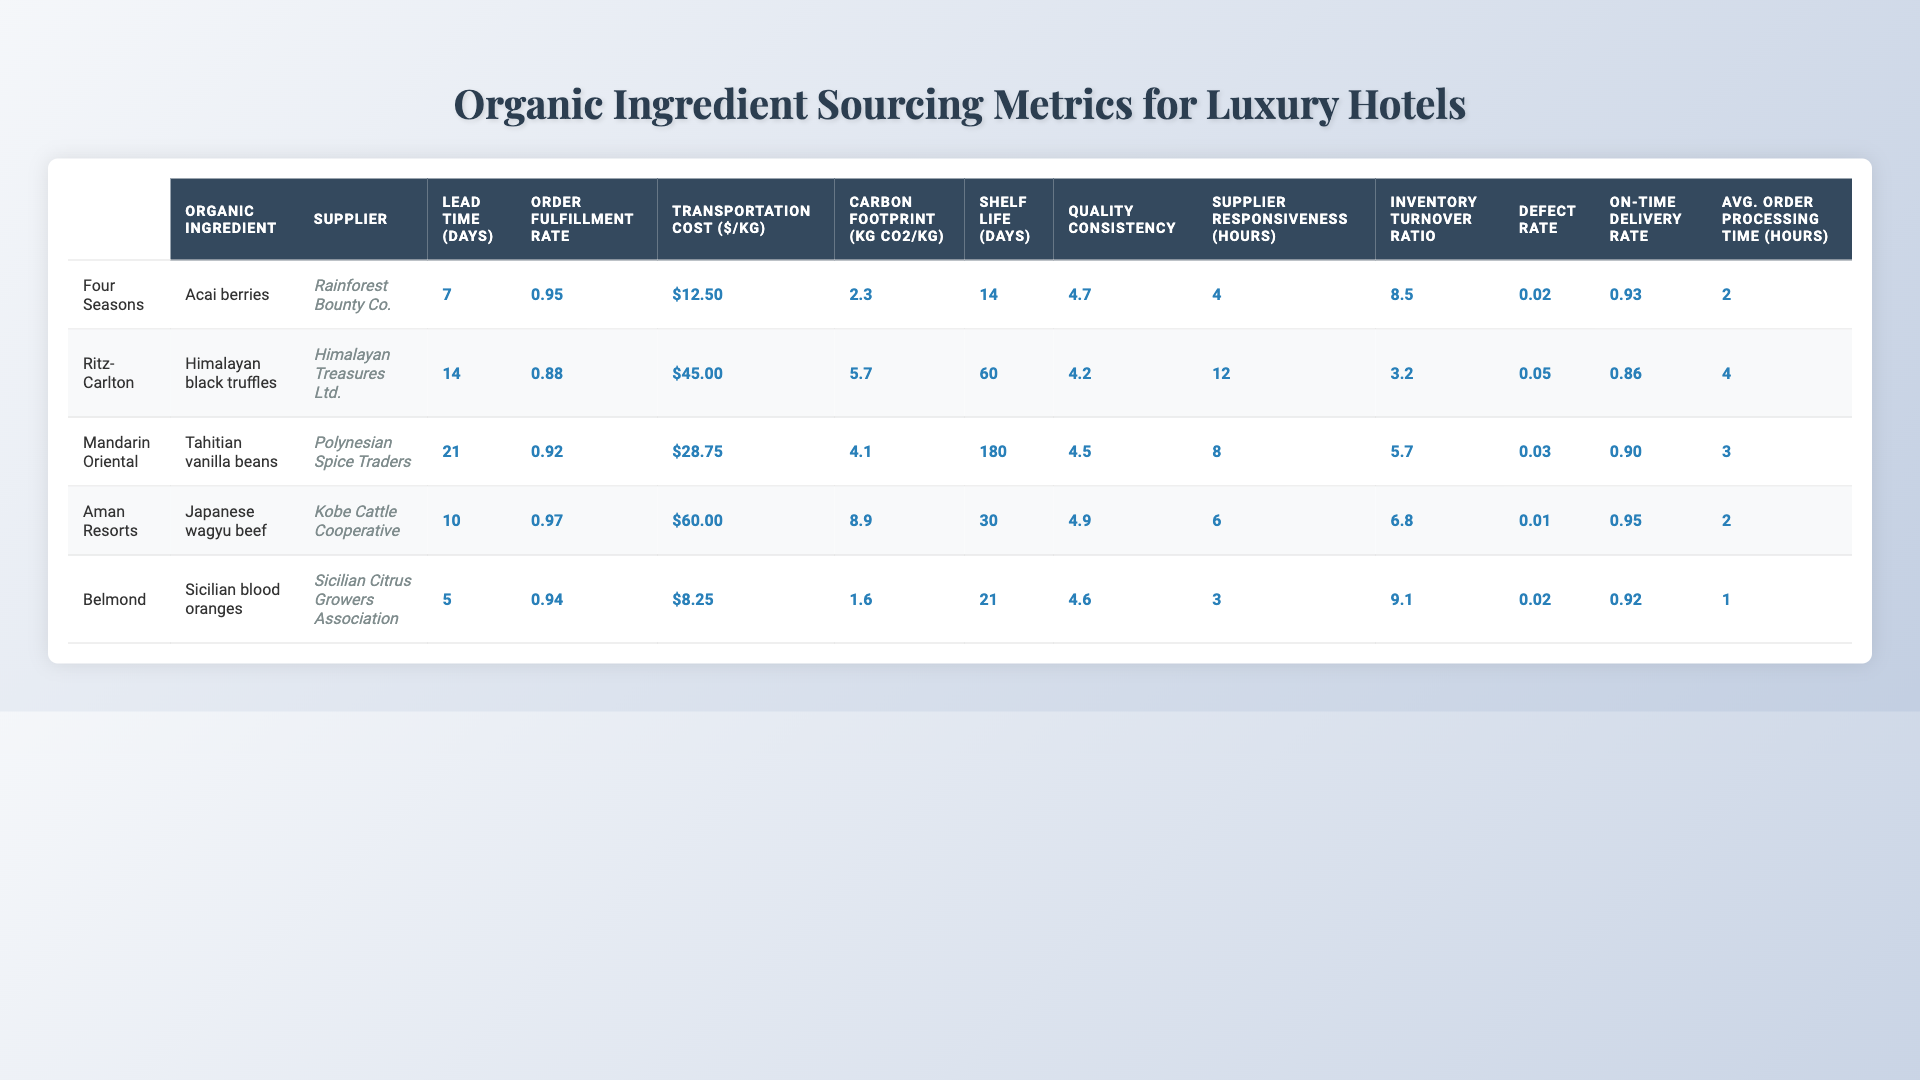What is the order fulfillment rate for Aman Resorts? The order fulfillment rate is listed in the table for Aman Resorts, which is 0.97.
Answer: 0.97 Which hotel chain has the highest transportation cost per kilogram? By comparing the transportation costs for each hotel chain, the Ritz-Carlton has the highest cost at $45.00 per kilogram.
Answer: Ritz-Carlton What is the average lead time for organic ingredient sourcing across all hotel chains? The lead times are 7, 14, 21, 10, and 5 days. The average is calculated by summing these values (7 + 14 + 21 + 10 + 5 = 57) and dividing by 5, which equals 57/5 = 11.4 days.
Answer: 11.4 days Which organic ingredient has the longest shelf life? Checking the shelf life values, Tahitian vanilla beans have the longest shelf life at 180 days.
Answer: Tahitian vanilla beans Is the defect rate for Japanese wagyu beef lower than 0.03? The defect rate for Japanese wagyu beef is 0.01, which is lower than 0.03, making the statement true.
Answer: Yes How does the carbon footprint of Sicilian blood oranges compare to that of Japanese wagyu beef? The carbon footprint for Sicilian blood oranges is 1.6 kg CO2/kg, while for Japanese wagyu beef it is 8.9 kg CO2/kg. Since 1.6 is less than 8.9, Sicilian blood oranges have a lower carbon footprint.
Answer: Sicilian blood oranges have a lower carbon footprint Which supplier has the fastest supplier responsiveness? The supplier responsiveness hours are 4, 12, 8, 6, and 3 hours. The supplier with the fastest responsiveness is Sicilian Citrus Growers Association at 3 hours.
Answer: Sicilian Citrus Growers Association What is the difference in inventory turnover ratios between Four Seasons and Belmond? The inventory turnover ratios are 8.5 for Four Seasons and 9.1 for Belmond. The difference is calculated by subtracting: 9.1 - 8.5 = 0.6.
Answer: 0.6 Does any hotel chain report a 100% on-time delivery rate? By examining the on-time delivery rates, none of the hotel chains have a rate of 1.0 (100%). The highest is 0.97 for Aman Resorts.
Answer: No Which hotel chain has the highest quality consistency score? By reviewing the quality consistency scores, Japanese wagyu beef for Aman Resorts has the highest score of 4.9.
Answer: Aman Resorts What is the average order processing time for the hotels listed? The average order processing times are 2, 4, 3, 2, and 1 hours. Their sum is (2 + 4 + 3 + 2 + 1 = 12) and dividing by 5 gives an average of 12/5 = 2.4 hours.
Answer: 2.4 hours 